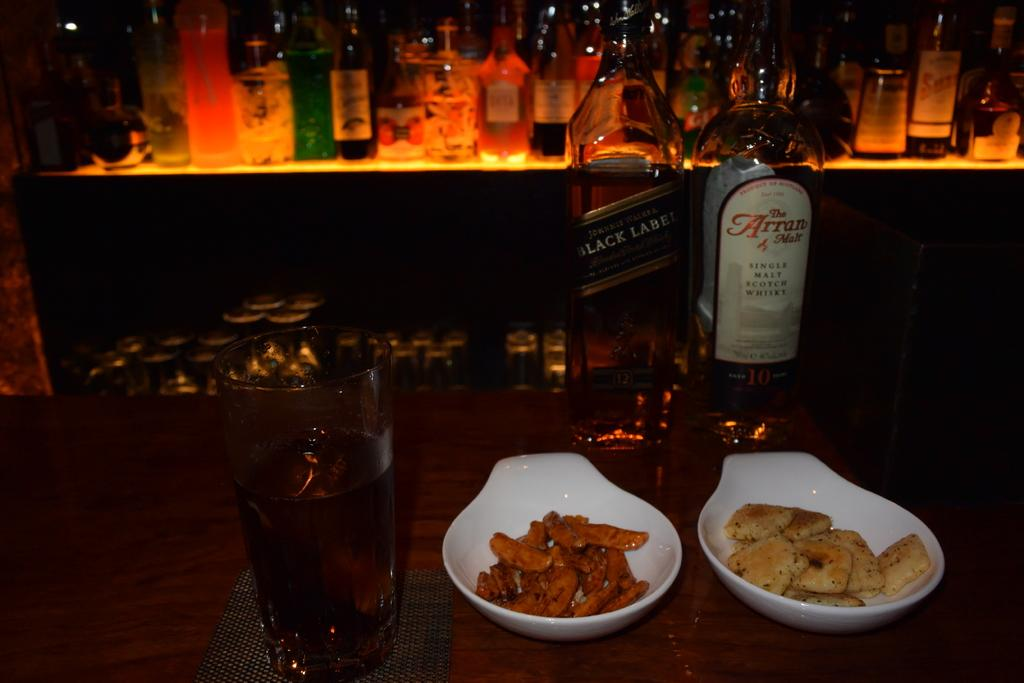How many bottles are visible in the image? There are two bottles in the image. What other objects can be seen on the table? There is a glass and a bowl containing food in the image. What might be used for drinking or eating in the image? The glass and the bowl containing food can be used for drinking and eating, respectively. Is there a picture of a squirrel on the table in the image? There is no picture of a squirrel present in the image. What type of growth can be observed on the table in the image? There is no growth visible on the table in the image. 